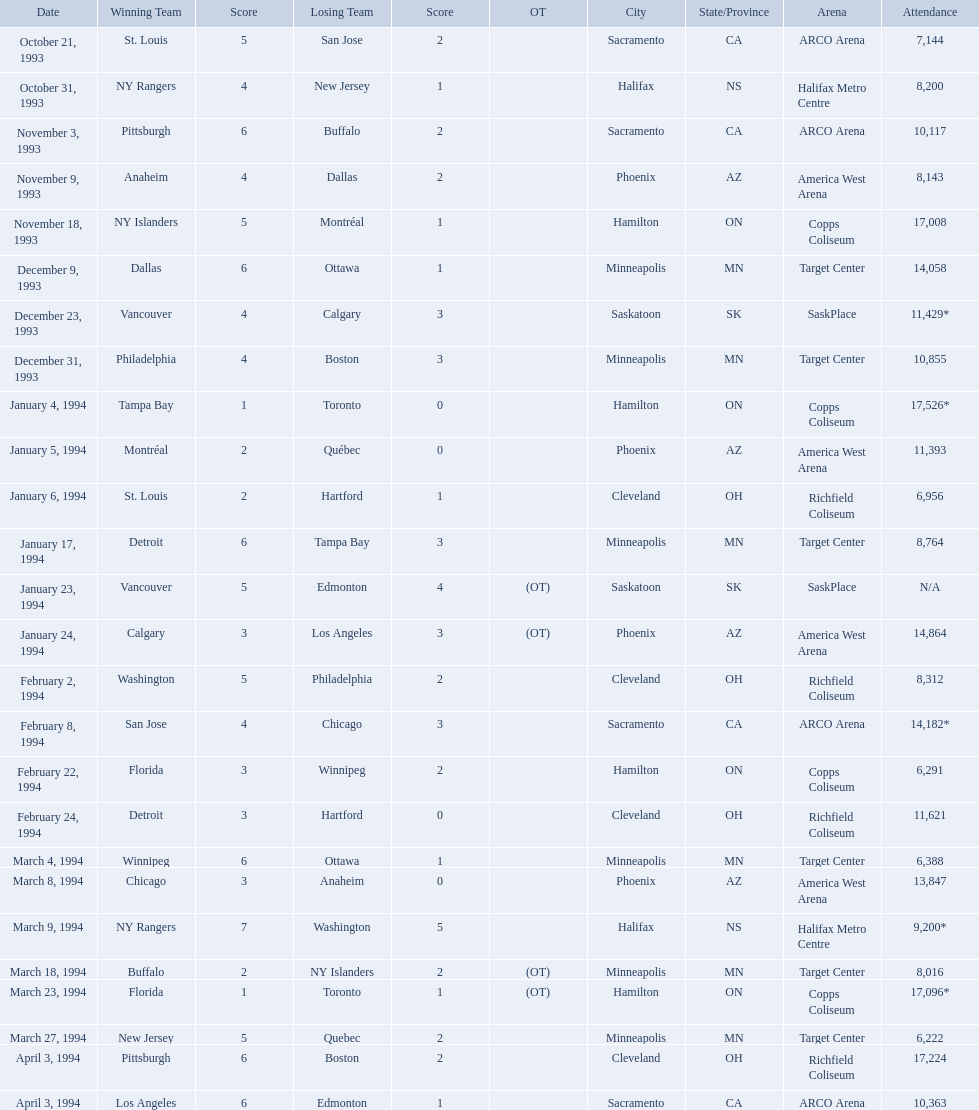On which dates were all the games? October 21, 1993, October 31, 1993, November 3, 1993, November 9, 1993, November 18, 1993, December 9, 1993, December 23, 1993, December 31, 1993, January 4, 1994, January 5, 1994, January 6, 1994, January 17, 1994, January 23, 1994, January 24, 1994, February 2, 1994, February 8, 1994, February 22, 1994, February 24, 1994, March 4, 1994, March 8, 1994, March 9, 1994, March 18, 1994, March 23, 1994, March 27, 1994, April 3, 1994, April 3, 1994. What were the attendances? 7,144, 8,200, 10,117, 8,143, 17,008, 14,058, 11,429*, 10,855, 17,526*, 11,393, 6,956, 8,764, N/A, 14,864, 8,312, 14,182*, 6,291, 11,621, 6,388, 13,847, 9,200*, 8,016, 17,096*, 6,222, 17,224, 10,363. And between december 23, 1993 and january 24, 1994, which game had the highest turnout? January 4, 1994. When were the games played? October 21, 1993, October 31, 1993, November 3, 1993, November 9, 1993, November 18, 1993, December 9, 1993, December 23, 1993, December 31, 1993, January 4, 1994, January 5, 1994, January 6, 1994, January 17, 1994, January 23, 1994, January 24, 1994, February 2, 1994, February 8, 1994, February 22, 1994, February 24, 1994, March 4, 1994, March 8, 1994, March 9, 1994, March 18, 1994, March 23, 1994, March 27, 1994, April 3, 1994, April 3, 1994. What was the attendance for those games? 7,144, 8,200, 10,117, 8,143, 17,008, 14,058, 11,429*, 10,855, 17,526*, 11,393, 6,956, 8,764, N/A, 14,864, 8,312, 14,182*, 6,291, 11,621, 6,388, 13,847, 9,200*, 8,016, 17,096*, 6,222, 17,224, 10,363. Which date had the highest attendance? January 4, 1994. Which dates did all the games take place? October 21, 1993, October 31, 1993, November 3, 1993, November 9, 1993, November 18, 1993, December 9, 1993, December 23, 1993, December 31, 1993, January 4, 1994, January 5, 1994, January 6, 1994, January 17, 1994, January 23, 1994, January 24, 1994, February 2, 1994, February 8, 1994, February 22, 1994, February 24, 1994, March 4, 1994, March 8, 1994, March 9, 1994, March 18, 1994, March 23, 1994, March 27, 1994, April 3, 1994, April 3, 1994. What were the crowd sizes? 7,144, 8,200, 10,117, 8,143, 17,008, 14,058, 11,429*, 10,855, 17,526*, 11,393, 6,956, 8,764, N/A, 14,864, 8,312, 14,182*, 6,291, 11,621, 6,388, 13,847, 9,200*, 8,016, 17,096*, 6,222, 17,224, 10,363. And from december 23, 1993 to january 24, 1994, which event had the largest number of spectators? January 4, 1994. When were all the games held? October 21, 1993, October 31, 1993, November 3, 1993, November 9, 1993, November 18, 1993, December 9, 1993, December 23, 1993, December 31, 1993, January 4, 1994, January 5, 1994, January 6, 1994, January 17, 1994, January 23, 1994, January 24, 1994, February 2, 1994, February 8, 1994, February 22, 1994, February 24, 1994, March 4, 1994, March 8, 1994, March 9, 1994, March 18, 1994, March 23, 1994, March 27, 1994, April 3, 1994, April 3, 1994. What were the attendance numbers? 7,144, 8,200, 10,117, 8,143, 17,008, 14,058, 11,429*, 10,855, 17,526*, 11,393, 6,956, 8,764, N/A, 14,864, 8,312, 14,182*, 6,291, 11,621, 6,388, 13,847, 9,200*, 8,016, 17,096*, 6,222, 17,224, 10,363. Between december 23, 1993, and january 24, 1994, which game experienced the largest audience? January 4, 1994. What were the dates of all the games? October 21, 1993, October 31, 1993, November 3, 1993, November 9, 1993, November 18, 1993, December 9, 1993, December 23, 1993, December 31, 1993, January 4, 1994, January 5, 1994, January 6, 1994, January 17, 1994, January 23, 1994, January 24, 1994, February 2, 1994, February 8, 1994, February 22, 1994, February 24, 1994, March 4, 1994, March 8, 1994, March 9, 1994, March 18, 1994, March 23, 1994, March 27, 1994, April 3, 1994, April 3, 1994. How many people attended each game? 7,144, 8,200, 10,117, 8,143, 17,008, 14,058, 11,429*, 10,855, 17,526*, 11,393, 6,956, 8,764, N/A, 14,864, 8,312, 14,182*, 6,291, 11,621, 6,388, 13,847, 9,200*, 8,016, 17,096*, 6,222, 17,224, 10,363. In the period between december 23, 1993, and january 24, 1994, which game attracted the highest number of spectators? January 4, 1994. During the 1993-94 nhl season, what were the attendance numbers? 7,144, 8,200, 10,117, 8,143, 17,008, 14,058, 11,429*, 10,855, 17,526*, 11,393, 6,956, 8,764, N/A, 14,864, 8,312, 14,182*, 6,291, 11,621, 6,388, 13,847, 9,200*, 8,016, 17,096*, 6,222, 17,224, 10,363. Which game had the most attendees? 17,526*. When did this game with the highest attendance occur? January 4, 1994. On what dates were the games held? October 21, 1993, October 31, 1993, November 3, 1993, November 9, 1993, November 18, 1993, December 9, 1993, December 23, 1993, December 31, 1993, January 4, 1994, January 5, 1994, January 6, 1994, January 17, 1994, January 23, 1994, January 24, 1994, February 2, 1994, February 8, 1994, February 22, 1994, February 24, 1994, March 4, 1994, March 8, 1994, March 9, 1994, March 18, 1994, March 23, 1994, March 27, 1994, April 3, 1994, April 3, 1994. What were the attendance figures for the games? 7,144, 8,200, 10,117, 8,143, 17,008, 14,058, 11,429*, 10,855, 17,526*, 11,393, 6,956, 8,764, N/A, 14,864, 8,312, 14,182*, 6,291, 11,621, 6,388, 13,847, 9,200*, 8,016, 17,096*, 6,222, 17,224, 10,363. Which date saw the largest crowd? January 4, 1994. 